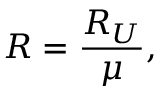Convert formula to latex. <formula><loc_0><loc_0><loc_500><loc_500>R = \frac { R _ { U } } { \mu } ,</formula> 